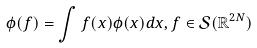<formula> <loc_0><loc_0><loc_500><loc_500>\phi ( f ) = \int f ( x ) \phi ( x ) d x , f \in \mathcal { S } ( \mathbb { R } ^ { 2 N } )</formula> 